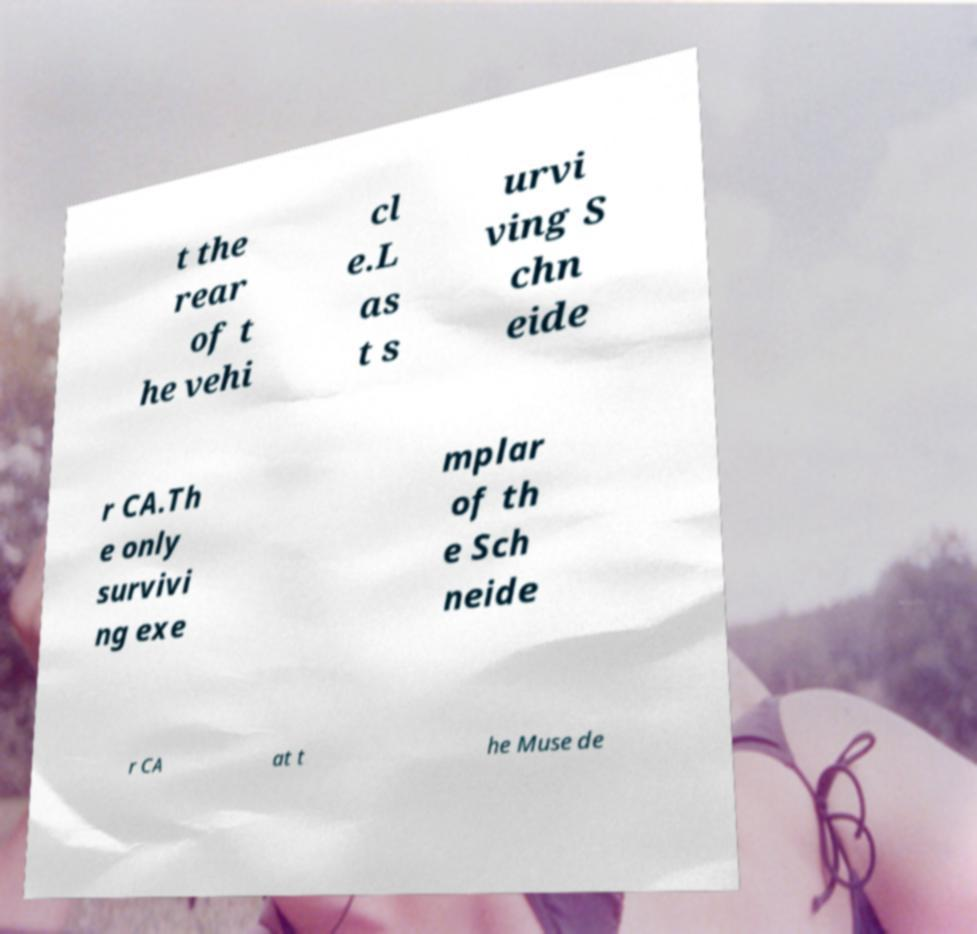I need the written content from this picture converted into text. Can you do that? t the rear of t he vehi cl e.L as t s urvi ving S chn eide r CA.Th e only survivi ng exe mplar of th e Sch neide r CA at t he Muse de 